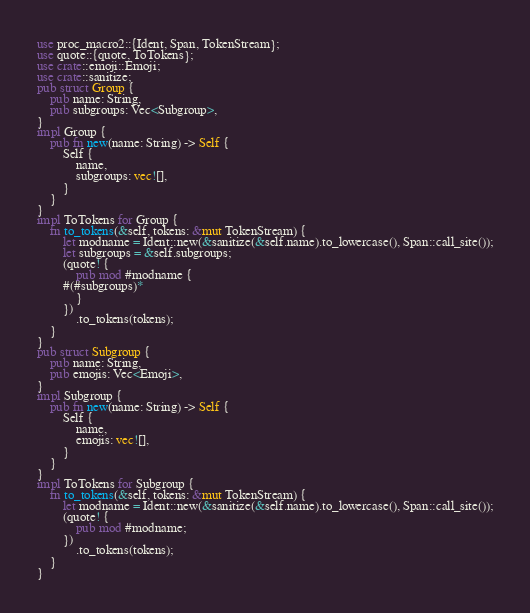Convert code to text. <code><loc_0><loc_0><loc_500><loc_500><_Rust_>use proc_macro2::{Ident, Span, TokenStream};
use quote::{quote, ToTokens};
use crate::emoji::Emoji;
use crate::sanitize;
pub struct Group {
    pub name: String,
    pub subgroups: Vec<Subgroup>,
}
impl Group {
    pub fn new(name: String) -> Self {
        Self {
            name,
            subgroups: vec![],
        }
    }
}
impl ToTokens for Group {
    fn to_tokens(&self, tokens: &mut TokenStream) {
        let modname = Ident::new(&sanitize(&self.name).to_lowercase(), Span::call_site());
        let subgroups = &self.subgroups;
        (quote! {
            pub mod #modname {
		#(#subgroups)*
            }
        })
            .to_tokens(tokens);
    }
}
pub struct Subgroup {
    pub name: String,
    pub emojis: Vec<Emoji>,
}
impl Subgroup {
    pub fn new(name: String) -> Self {
        Self {
            name,
            emojis: vec![],
        }
    }
}
impl ToTokens for Subgroup {
    fn to_tokens(&self, tokens: &mut TokenStream) {
        let modname = Ident::new(&sanitize(&self.name).to_lowercase(), Span::call_site());
        (quote! {
            pub mod #modname;
        })
            .to_tokens(tokens);
    }
}
</code> 